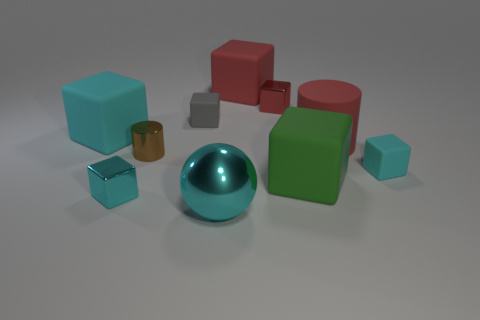Subtract all red matte blocks. How many blocks are left? 6 Subtract all cubes. How many objects are left? 3 Subtract 6 cubes. How many cubes are left? 1 Subtract all red cubes. How many cubes are left? 5 Subtract 0 cyan cylinders. How many objects are left? 10 Subtract all gray blocks. Subtract all brown balls. How many blocks are left? 6 Subtract all purple blocks. How many red cylinders are left? 1 Subtract all large yellow matte balls. Subtract all tiny cylinders. How many objects are left? 9 Add 2 red things. How many red things are left? 5 Add 5 big cyan cubes. How many big cyan cubes exist? 6 